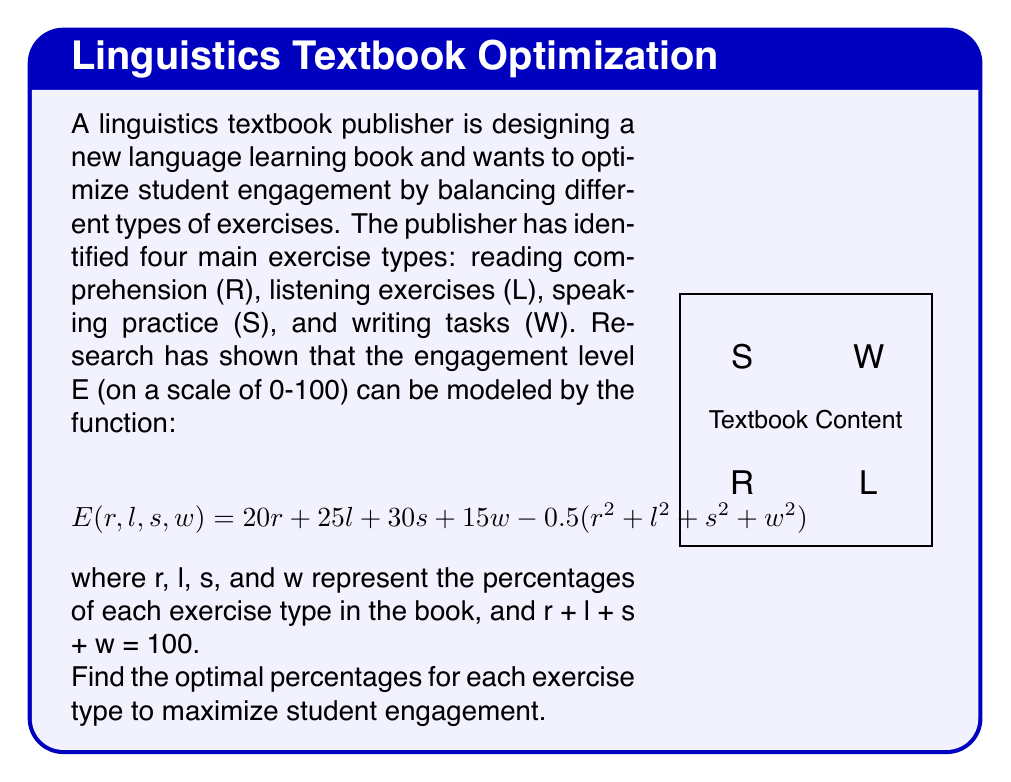Solve this math problem. To solve this optimization problem, we can use the method of Lagrange multipliers:

1) Define the Lagrangian function:
   $$L(r,l,s,w,λ) = E(r,l,s,w) - λ(r+l+s+w-100)$$

2) Calculate partial derivatives and set them equal to zero:
   $$\frac{\partial L}{\partial r} = 20 - r - λ = 0$$
   $$\frac{\partial L}{\partial l} = 25 - l - λ = 0$$
   $$\frac{\partial L}{\partial s} = 30 - s - λ = 0$$
   $$\frac{\partial L}{\partial w} = 15 - w - λ = 0$$
   $$\frac{\partial L}{\partial λ} = r + l + s + w - 100 = 0$$

3) From these equations, we can deduce:
   $$r = 20 - λ$$
   $$l = 25 - λ$$
   $$s = 30 - λ$$
   $$w = 15 - λ$$

4) Substitute these into the constraint equation:
   $$(20-λ) + (25-λ) + (30-λ) + (15-λ) = 100$$
   $$90 - 4λ = 100$$
   $$-4λ = 10$$
   $$λ = -2.5$$

5) Now we can calculate the optimal percentages:
   $$r = 20 - (-2.5) = 22.5\%$$
   $$l = 25 - (-2.5) = 27.5\%$$
   $$s = 30 - (-2.5) = 32.5\%$$
   $$w = 15 - (-2.5) = 17.5\%$$

6) Verify that these percentages sum to 100%:
   $$22.5 + 27.5 + 32.5 + 17.5 = 100\%$$

Therefore, the optimal percentages for each exercise type are: 22.5% for reading comprehension, 27.5% for listening exercises, 32.5% for speaking practice, and 17.5% for writing tasks.
Answer: R: 22.5%, L: 27.5%, S: 32.5%, W: 17.5% 